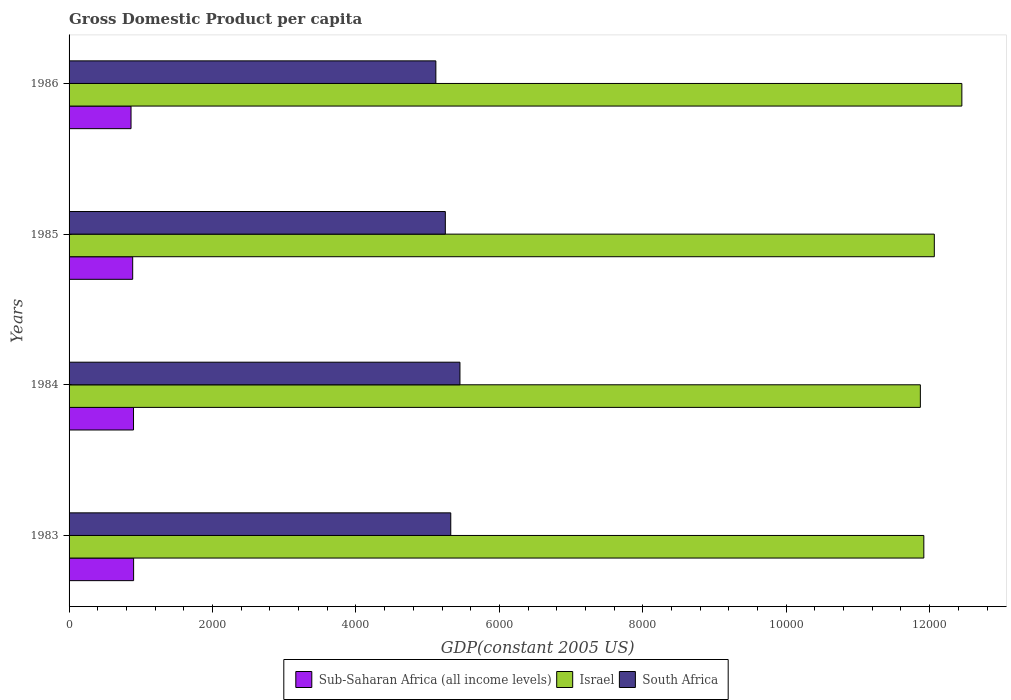Are the number of bars per tick equal to the number of legend labels?
Your response must be concise. Yes. Are the number of bars on each tick of the Y-axis equal?
Your answer should be very brief. Yes. In how many cases, is the number of bars for a given year not equal to the number of legend labels?
Your response must be concise. 0. What is the GDP per capita in Israel in 1985?
Keep it short and to the point. 1.21e+04. Across all years, what is the maximum GDP per capita in Sub-Saharan Africa (all income levels)?
Ensure brevity in your answer.  899.84. Across all years, what is the minimum GDP per capita in South Africa?
Offer a very short reply. 5114.44. In which year was the GDP per capita in Israel minimum?
Keep it short and to the point. 1984. What is the total GDP per capita in Israel in the graph?
Make the answer very short. 4.83e+04. What is the difference between the GDP per capita in Israel in 1983 and that in 1984?
Ensure brevity in your answer.  48.43. What is the difference between the GDP per capita in South Africa in 1983 and the GDP per capita in Sub-Saharan Africa (all income levels) in 1984?
Your answer should be very brief. 4423.73. What is the average GDP per capita in Sub-Saharan Africa (all income levels) per year?
Offer a very short reply. 887.33. In the year 1985, what is the difference between the GDP per capita in Israel and GDP per capita in South Africa?
Give a very brief answer. 6818.37. What is the ratio of the GDP per capita in South Africa in 1984 to that in 1985?
Your response must be concise. 1.04. Is the GDP per capita in Sub-Saharan Africa (all income levels) in 1983 less than that in 1986?
Provide a succinct answer. No. What is the difference between the highest and the second highest GDP per capita in Israel?
Offer a very short reply. 383.98. What is the difference between the highest and the lowest GDP per capita in Israel?
Offer a very short reply. 578.57. What does the 1st bar from the top in 1983 represents?
Offer a very short reply. South Africa. What does the 2nd bar from the bottom in 1984 represents?
Give a very brief answer. Israel. How many bars are there?
Your answer should be compact. 12. Are all the bars in the graph horizontal?
Your answer should be compact. Yes. Does the graph contain grids?
Offer a terse response. No. Where does the legend appear in the graph?
Offer a very short reply. Bottom center. How many legend labels are there?
Offer a terse response. 3. What is the title of the graph?
Ensure brevity in your answer.  Gross Domestic Product per capita. Does "Madagascar" appear as one of the legend labels in the graph?
Ensure brevity in your answer.  No. What is the label or title of the X-axis?
Provide a succinct answer. GDP(constant 2005 US). What is the label or title of the Y-axis?
Provide a short and direct response. Years. What is the GDP(constant 2005 US) of Sub-Saharan Africa (all income levels) in 1983?
Make the answer very short. 899.84. What is the GDP(constant 2005 US) in Israel in 1983?
Offer a terse response. 1.19e+04. What is the GDP(constant 2005 US) of South Africa in 1983?
Give a very brief answer. 5322.31. What is the GDP(constant 2005 US) of Sub-Saharan Africa (all income levels) in 1984?
Make the answer very short. 898.58. What is the GDP(constant 2005 US) of Israel in 1984?
Offer a terse response. 1.19e+04. What is the GDP(constant 2005 US) of South Africa in 1984?
Your answer should be very brief. 5450.43. What is the GDP(constant 2005 US) of Sub-Saharan Africa (all income levels) in 1985?
Provide a succinct answer. 886.98. What is the GDP(constant 2005 US) of Israel in 1985?
Give a very brief answer. 1.21e+04. What is the GDP(constant 2005 US) in South Africa in 1985?
Keep it short and to the point. 5246.38. What is the GDP(constant 2005 US) in Sub-Saharan Africa (all income levels) in 1986?
Keep it short and to the point. 863.9. What is the GDP(constant 2005 US) in Israel in 1986?
Provide a succinct answer. 1.24e+04. What is the GDP(constant 2005 US) of South Africa in 1986?
Offer a very short reply. 5114.44. Across all years, what is the maximum GDP(constant 2005 US) of Sub-Saharan Africa (all income levels)?
Ensure brevity in your answer.  899.84. Across all years, what is the maximum GDP(constant 2005 US) of Israel?
Ensure brevity in your answer.  1.24e+04. Across all years, what is the maximum GDP(constant 2005 US) of South Africa?
Your response must be concise. 5450.43. Across all years, what is the minimum GDP(constant 2005 US) of Sub-Saharan Africa (all income levels)?
Give a very brief answer. 863.9. Across all years, what is the minimum GDP(constant 2005 US) of Israel?
Give a very brief answer. 1.19e+04. Across all years, what is the minimum GDP(constant 2005 US) of South Africa?
Provide a succinct answer. 5114.44. What is the total GDP(constant 2005 US) in Sub-Saharan Africa (all income levels) in the graph?
Keep it short and to the point. 3549.31. What is the total GDP(constant 2005 US) in Israel in the graph?
Offer a very short reply. 4.83e+04. What is the total GDP(constant 2005 US) in South Africa in the graph?
Offer a terse response. 2.11e+04. What is the difference between the GDP(constant 2005 US) of Sub-Saharan Africa (all income levels) in 1983 and that in 1984?
Ensure brevity in your answer.  1.26. What is the difference between the GDP(constant 2005 US) of Israel in 1983 and that in 1984?
Make the answer very short. 48.43. What is the difference between the GDP(constant 2005 US) of South Africa in 1983 and that in 1984?
Your response must be concise. -128.11. What is the difference between the GDP(constant 2005 US) of Sub-Saharan Africa (all income levels) in 1983 and that in 1985?
Keep it short and to the point. 12.86. What is the difference between the GDP(constant 2005 US) in Israel in 1983 and that in 1985?
Offer a very short reply. -146.16. What is the difference between the GDP(constant 2005 US) of South Africa in 1983 and that in 1985?
Offer a very short reply. 75.93. What is the difference between the GDP(constant 2005 US) of Sub-Saharan Africa (all income levels) in 1983 and that in 1986?
Your answer should be compact. 35.94. What is the difference between the GDP(constant 2005 US) of Israel in 1983 and that in 1986?
Provide a succinct answer. -530.14. What is the difference between the GDP(constant 2005 US) in South Africa in 1983 and that in 1986?
Provide a succinct answer. 207.88. What is the difference between the GDP(constant 2005 US) in Sub-Saharan Africa (all income levels) in 1984 and that in 1985?
Your answer should be very brief. 11.6. What is the difference between the GDP(constant 2005 US) of Israel in 1984 and that in 1985?
Make the answer very short. -194.6. What is the difference between the GDP(constant 2005 US) in South Africa in 1984 and that in 1985?
Make the answer very short. 204.05. What is the difference between the GDP(constant 2005 US) of Sub-Saharan Africa (all income levels) in 1984 and that in 1986?
Keep it short and to the point. 34.68. What is the difference between the GDP(constant 2005 US) in Israel in 1984 and that in 1986?
Offer a very short reply. -578.57. What is the difference between the GDP(constant 2005 US) of South Africa in 1984 and that in 1986?
Your answer should be very brief. 335.99. What is the difference between the GDP(constant 2005 US) in Sub-Saharan Africa (all income levels) in 1985 and that in 1986?
Make the answer very short. 23.08. What is the difference between the GDP(constant 2005 US) of Israel in 1985 and that in 1986?
Your answer should be compact. -383.98. What is the difference between the GDP(constant 2005 US) of South Africa in 1985 and that in 1986?
Your response must be concise. 131.94. What is the difference between the GDP(constant 2005 US) of Sub-Saharan Africa (all income levels) in 1983 and the GDP(constant 2005 US) of Israel in 1984?
Give a very brief answer. -1.10e+04. What is the difference between the GDP(constant 2005 US) of Sub-Saharan Africa (all income levels) in 1983 and the GDP(constant 2005 US) of South Africa in 1984?
Your answer should be compact. -4550.59. What is the difference between the GDP(constant 2005 US) of Israel in 1983 and the GDP(constant 2005 US) of South Africa in 1984?
Offer a terse response. 6468.16. What is the difference between the GDP(constant 2005 US) of Sub-Saharan Africa (all income levels) in 1983 and the GDP(constant 2005 US) of Israel in 1985?
Provide a succinct answer. -1.12e+04. What is the difference between the GDP(constant 2005 US) of Sub-Saharan Africa (all income levels) in 1983 and the GDP(constant 2005 US) of South Africa in 1985?
Your response must be concise. -4346.54. What is the difference between the GDP(constant 2005 US) in Israel in 1983 and the GDP(constant 2005 US) in South Africa in 1985?
Give a very brief answer. 6672.21. What is the difference between the GDP(constant 2005 US) of Sub-Saharan Africa (all income levels) in 1983 and the GDP(constant 2005 US) of Israel in 1986?
Ensure brevity in your answer.  -1.15e+04. What is the difference between the GDP(constant 2005 US) of Sub-Saharan Africa (all income levels) in 1983 and the GDP(constant 2005 US) of South Africa in 1986?
Your response must be concise. -4214.59. What is the difference between the GDP(constant 2005 US) in Israel in 1983 and the GDP(constant 2005 US) in South Africa in 1986?
Your response must be concise. 6804.15. What is the difference between the GDP(constant 2005 US) in Sub-Saharan Africa (all income levels) in 1984 and the GDP(constant 2005 US) in Israel in 1985?
Offer a very short reply. -1.12e+04. What is the difference between the GDP(constant 2005 US) of Sub-Saharan Africa (all income levels) in 1984 and the GDP(constant 2005 US) of South Africa in 1985?
Your answer should be compact. -4347.8. What is the difference between the GDP(constant 2005 US) in Israel in 1984 and the GDP(constant 2005 US) in South Africa in 1985?
Give a very brief answer. 6623.78. What is the difference between the GDP(constant 2005 US) of Sub-Saharan Africa (all income levels) in 1984 and the GDP(constant 2005 US) of Israel in 1986?
Your response must be concise. -1.16e+04. What is the difference between the GDP(constant 2005 US) of Sub-Saharan Africa (all income levels) in 1984 and the GDP(constant 2005 US) of South Africa in 1986?
Offer a terse response. -4215.85. What is the difference between the GDP(constant 2005 US) of Israel in 1984 and the GDP(constant 2005 US) of South Africa in 1986?
Provide a short and direct response. 6755.72. What is the difference between the GDP(constant 2005 US) of Sub-Saharan Africa (all income levels) in 1985 and the GDP(constant 2005 US) of Israel in 1986?
Ensure brevity in your answer.  -1.16e+04. What is the difference between the GDP(constant 2005 US) in Sub-Saharan Africa (all income levels) in 1985 and the GDP(constant 2005 US) in South Africa in 1986?
Provide a short and direct response. -4227.45. What is the difference between the GDP(constant 2005 US) in Israel in 1985 and the GDP(constant 2005 US) in South Africa in 1986?
Your answer should be compact. 6950.32. What is the average GDP(constant 2005 US) in Sub-Saharan Africa (all income levels) per year?
Offer a terse response. 887.33. What is the average GDP(constant 2005 US) of Israel per year?
Give a very brief answer. 1.21e+04. What is the average GDP(constant 2005 US) in South Africa per year?
Your response must be concise. 5283.39. In the year 1983, what is the difference between the GDP(constant 2005 US) in Sub-Saharan Africa (all income levels) and GDP(constant 2005 US) in Israel?
Keep it short and to the point. -1.10e+04. In the year 1983, what is the difference between the GDP(constant 2005 US) in Sub-Saharan Africa (all income levels) and GDP(constant 2005 US) in South Africa?
Provide a short and direct response. -4422.47. In the year 1983, what is the difference between the GDP(constant 2005 US) in Israel and GDP(constant 2005 US) in South Africa?
Give a very brief answer. 6596.27. In the year 1984, what is the difference between the GDP(constant 2005 US) of Sub-Saharan Africa (all income levels) and GDP(constant 2005 US) of Israel?
Offer a terse response. -1.10e+04. In the year 1984, what is the difference between the GDP(constant 2005 US) of Sub-Saharan Africa (all income levels) and GDP(constant 2005 US) of South Africa?
Your answer should be very brief. -4551.84. In the year 1984, what is the difference between the GDP(constant 2005 US) of Israel and GDP(constant 2005 US) of South Africa?
Your answer should be compact. 6419.73. In the year 1985, what is the difference between the GDP(constant 2005 US) of Sub-Saharan Africa (all income levels) and GDP(constant 2005 US) of Israel?
Your answer should be very brief. -1.12e+04. In the year 1985, what is the difference between the GDP(constant 2005 US) of Sub-Saharan Africa (all income levels) and GDP(constant 2005 US) of South Africa?
Your answer should be very brief. -4359.4. In the year 1985, what is the difference between the GDP(constant 2005 US) in Israel and GDP(constant 2005 US) in South Africa?
Your answer should be very brief. 6818.37. In the year 1986, what is the difference between the GDP(constant 2005 US) of Sub-Saharan Africa (all income levels) and GDP(constant 2005 US) of Israel?
Your response must be concise. -1.16e+04. In the year 1986, what is the difference between the GDP(constant 2005 US) of Sub-Saharan Africa (all income levels) and GDP(constant 2005 US) of South Africa?
Ensure brevity in your answer.  -4250.54. In the year 1986, what is the difference between the GDP(constant 2005 US) in Israel and GDP(constant 2005 US) in South Africa?
Provide a short and direct response. 7334.29. What is the ratio of the GDP(constant 2005 US) of Sub-Saharan Africa (all income levels) in 1983 to that in 1984?
Your answer should be compact. 1. What is the ratio of the GDP(constant 2005 US) in South Africa in 1983 to that in 1984?
Your answer should be compact. 0.98. What is the ratio of the GDP(constant 2005 US) of Sub-Saharan Africa (all income levels) in 1983 to that in 1985?
Your answer should be very brief. 1.01. What is the ratio of the GDP(constant 2005 US) of Israel in 1983 to that in 1985?
Offer a terse response. 0.99. What is the ratio of the GDP(constant 2005 US) in South Africa in 1983 to that in 1985?
Offer a terse response. 1.01. What is the ratio of the GDP(constant 2005 US) in Sub-Saharan Africa (all income levels) in 1983 to that in 1986?
Your answer should be very brief. 1.04. What is the ratio of the GDP(constant 2005 US) in Israel in 1983 to that in 1986?
Make the answer very short. 0.96. What is the ratio of the GDP(constant 2005 US) of South Africa in 1983 to that in 1986?
Provide a short and direct response. 1.04. What is the ratio of the GDP(constant 2005 US) in Sub-Saharan Africa (all income levels) in 1984 to that in 1985?
Offer a very short reply. 1.01. What is the ratio of the GDP(constant 2005 US) of Israel in 1984 to that in 1985?
Ensure brevity in your answer.  0.98. What is the ratio of the GDP(constant 2005 US) in South Africa in 1984 to that in 1985?
Make the answer very short. 1.04. What is the ratio of the GDP(constant 2005 US) in Sub-Saharan Africa (all income levels) in 1984 to that in 1986?
Offer a terse response. 1.04. What is the ratio of the GDP(constant 2005 US) of Israel in 1984 to that in 1986?
Your answer should be very brief. 0.95. What is the ratio of the GDP(constant 2005 US) of South Africa in 1984 to that in 1986?
Make the answer very short. 1.07. What is the ratio of the GDP(constant 2005 US) of Sub-Saharan Africa (all income levels) in 1985 to that in 1986?
Your answer should be compact. 1.03. What is the ratio of the GDP(constant 2005 US) in Israel in 1985 to that in 1986?
Make the answer very short. 0.97. What is the ratio of the GDP(constant 2005 US) of South Africa in 1985 to that in 1986?
Offer a terse response. 1.03. What is the difference between the highest and the second highest GDP(constant 2005 US) in Sub-Saharan Africa (all income levels)?
Your answer should be very brief. 1.26. What is the difference between the highest and the second highest GDP(constant 2005 US) of Israel?
Give a very brief answer. 383.98. What is the difference between the highest and the second highest GDP(constant 2005 US) of South Africa?
Make the answer very short. 128.11. What is the difference between the highest and the lowest GDP(constant 2005 US) of Sub-Saharan Africa (all income levels)?
Provide a succinct answer. 35.94. What is the difference between the highest and the lowest GDP(constant 2005 US) in Israel?
Your answer should be very brief. 578.57. What is the difference between the highest and the lowest GDP(constant 2005 US) in South Africa?
Give a very brief answer. 335.99. 